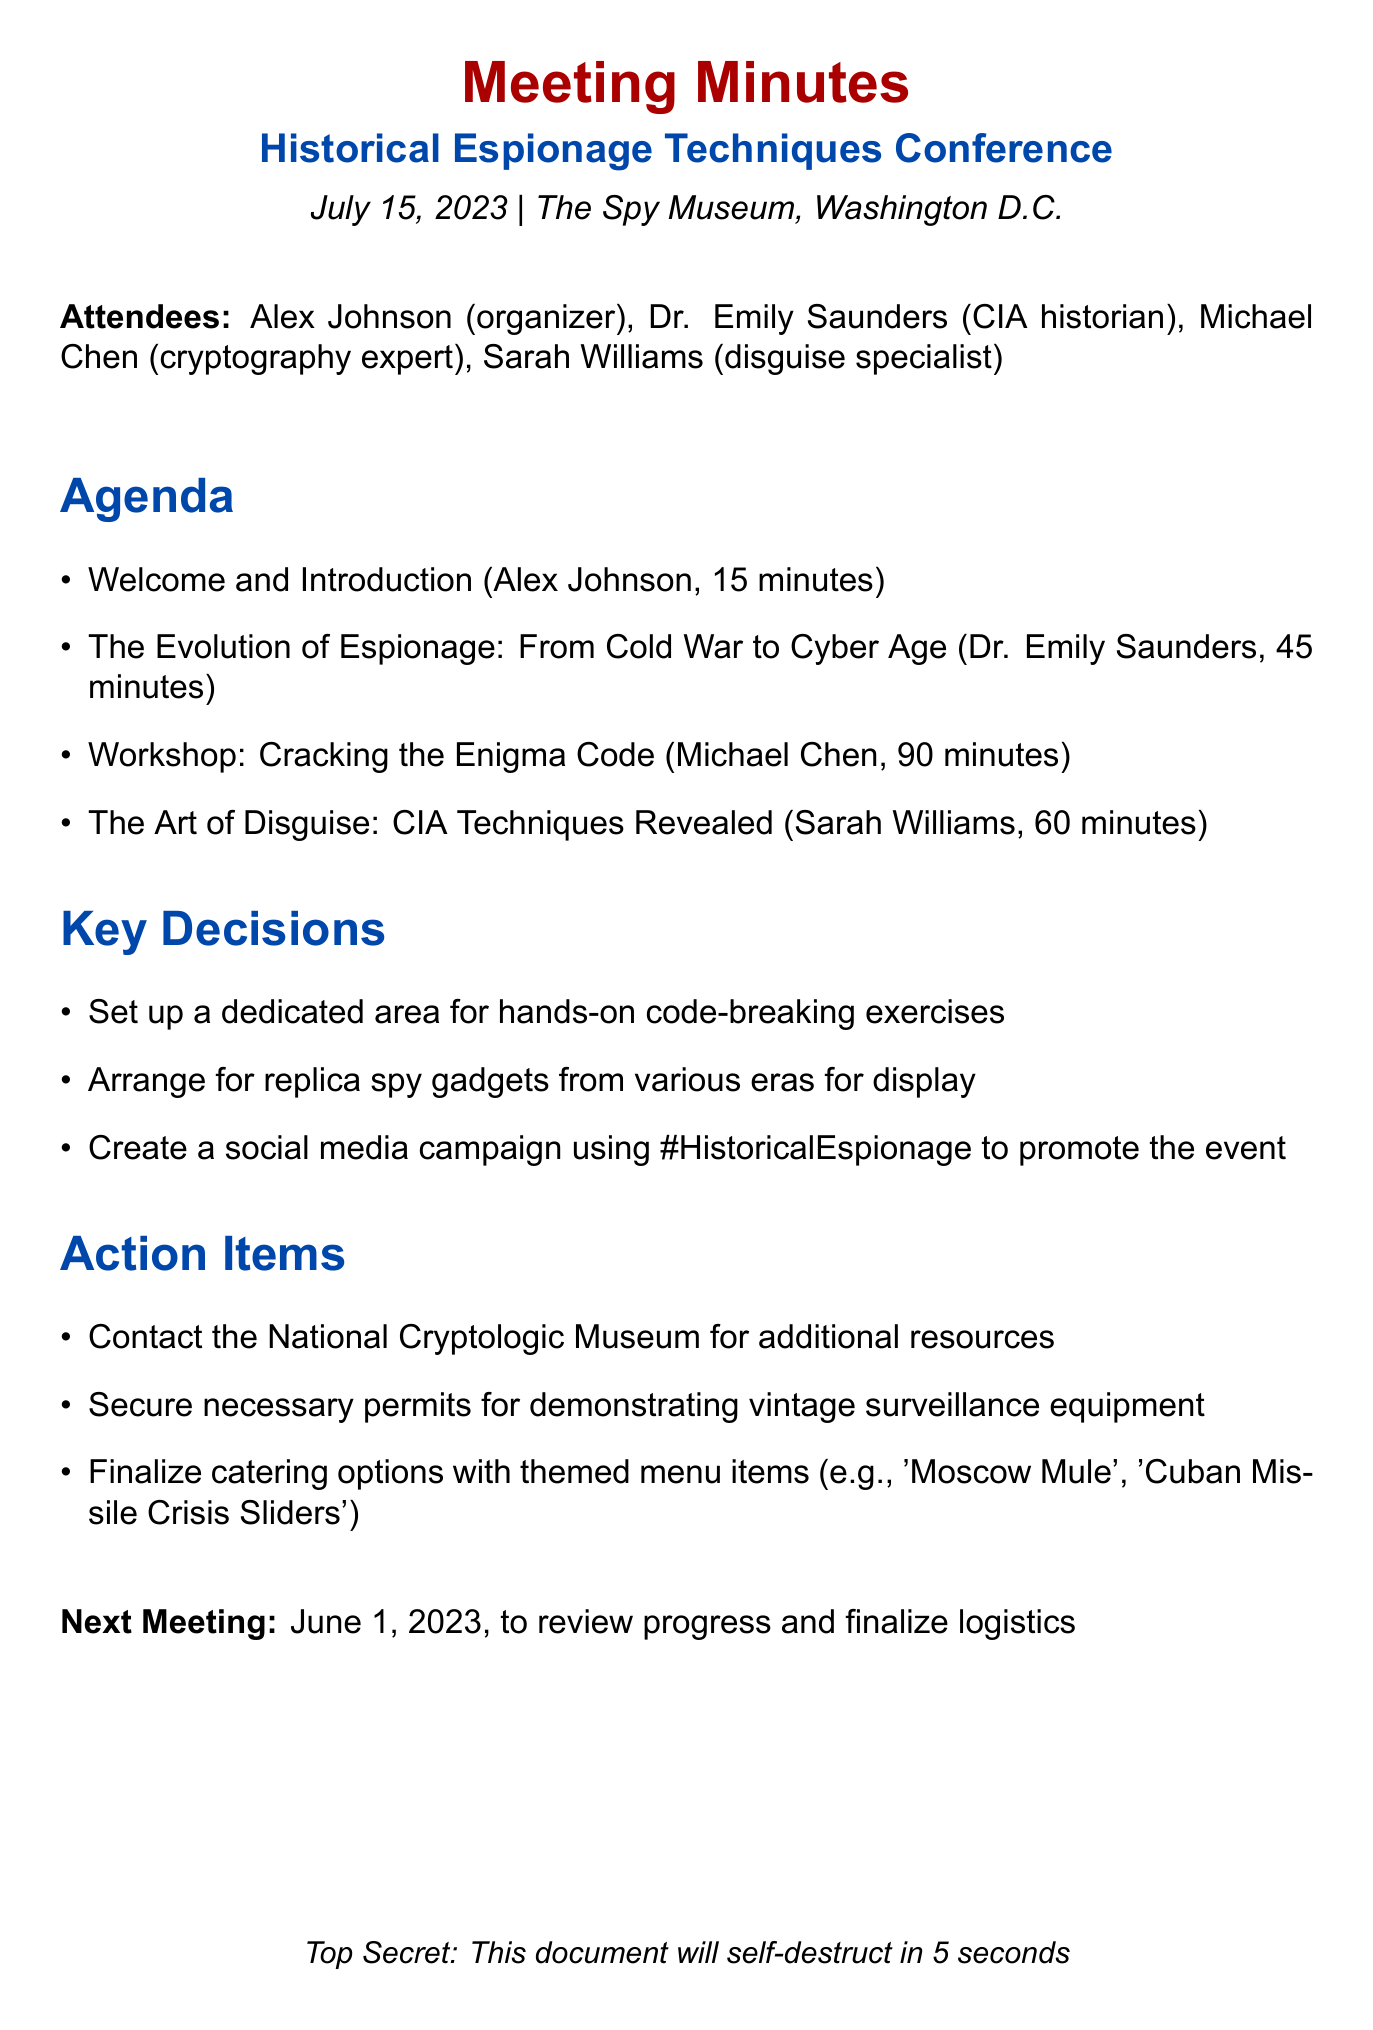What is the date of the conference? The date of the conference is listed directly in the document as July 15, 2023.
Answer: July 15, 2023 Who is the organizer of the conference? The organizer is mentioned in the attendees list as Alex Johnson.
Answer: Alex Johnson How long is the presentation on the evolution of espionage? The duration of the presentation is stated as 45 minutes.
Answer: 45 minutes What is one of the key decisions made during the meeting? The document lists multiple key decisions, one being to set up a dedicated area for hands-on code-breaking exercises.
Answer: Set up a dedicated area for hands-on code-breaking exercises When is the next meeting scheduled? The next meeting date is mentioned as June 1, 2023, for reviewing progress and finalizing logistics.
Answer: June 1, 2023 What topic will Michael Chen present? The topic presented by Michael Chen is specified as "Workshop: Cracking the Enigma Code."
Answer: Workshop: Cracking the Enigma Code What type of catering options are being finalized? The catering discussion is about themed menu items, including 'Moscow Mule' and 'Cuban Missile Crisis Sliders.'
Answer: Themed menu items How long is the workshop on disguise techniques? The document states that Sarah Williams' workshop lasts for 60 minutes.
Answer: 60 minutes 